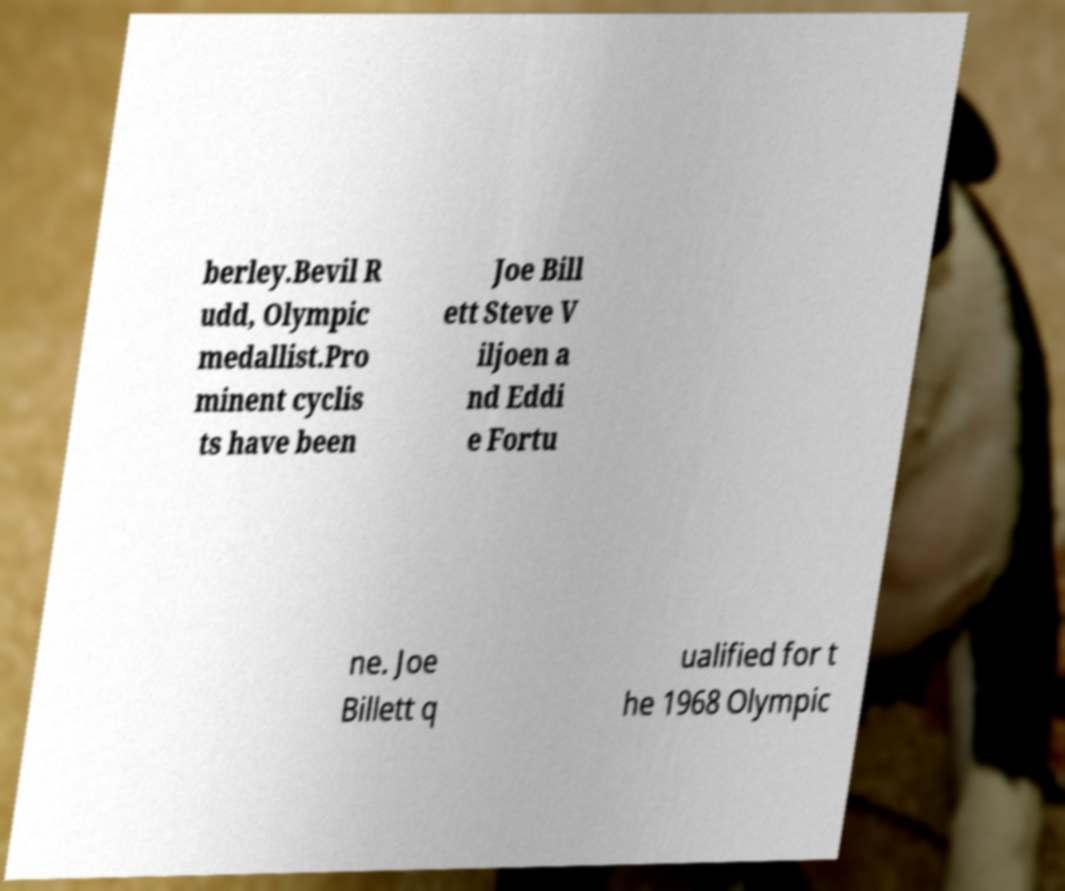Please identify and transcribe the text found in this image. berley.Bevil R udd, Olympic medallist.Pro minent cyclis ts have been Joe Bill ett Steve V iljoen a nd Eddi e Fortu ne. Joe Billett q ualified for t he 1968 Olympic 